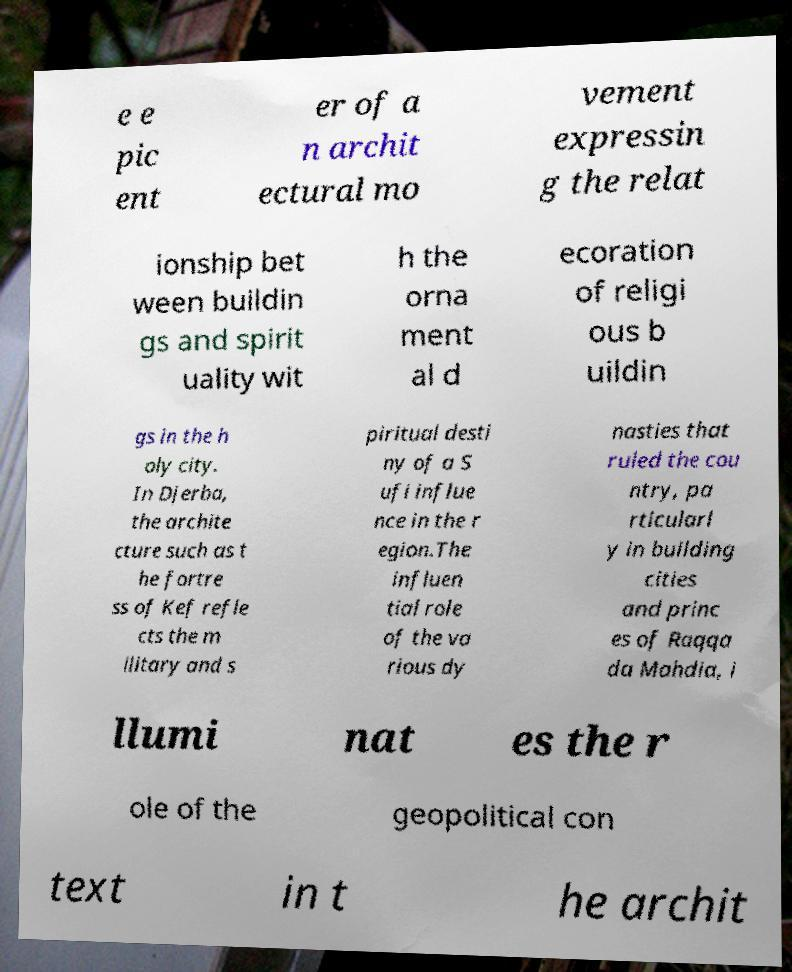Could you assist in decoding the text presented in this image and type it out clearly? e e pic ent er of a n archit ectural mo vement expressin g the relat ionship bet ween buildin gs and spirit uality wit h the orna ment al d ecoration of religi ous b uildin gs in the h oly city. In Djerba, the archite cture such as t he fortre ss of Kef refle cts the m ilitary and s piritual desti ny of a S ufi influe nce in the r egion.The influen tial role of the va rious dy nasties that ruled the cou ntry, pa rticularl y in building cities and princ es of Raqqa da Mahdia, i llumi nat es the r ole of the geopolitical con text in t he archit 